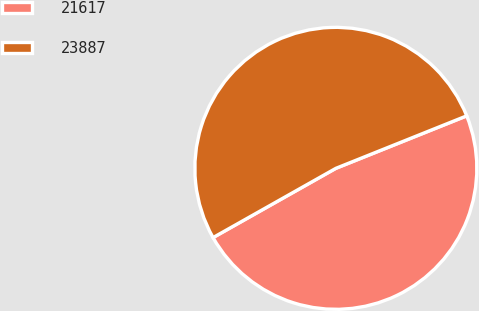Convert chart. <chart><loc_0><loc_0><loc_500><loc_500><pie_chart><fcel>21617<fcel>23887<nl><fcel>47.9%<fcel>52.1%<nl></chart> 